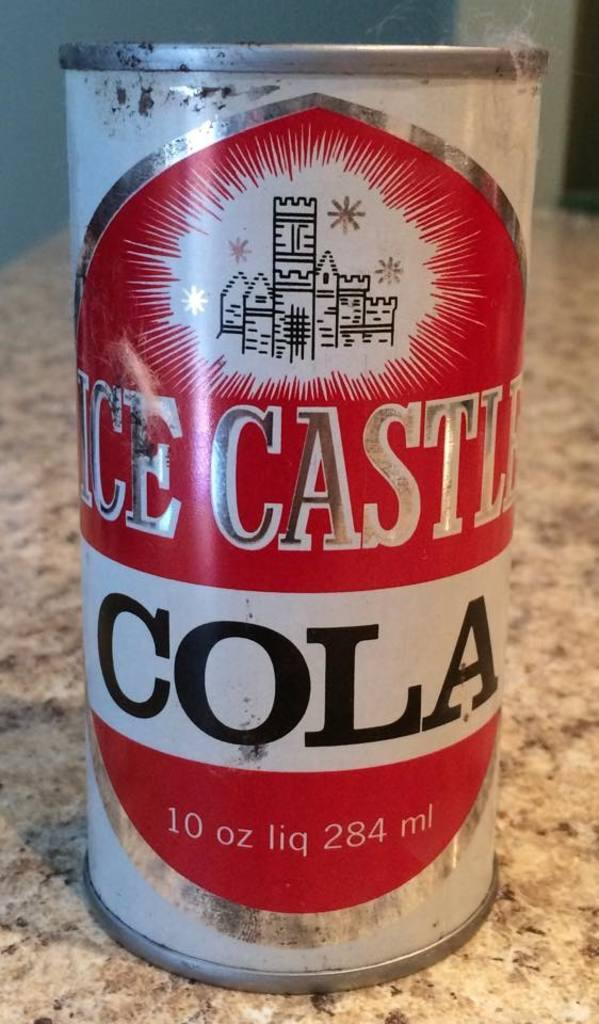<image>
Relay a brief, clear account of the picture shown. A can of Ice Castle Cola contains 10 ounces of liquid. 